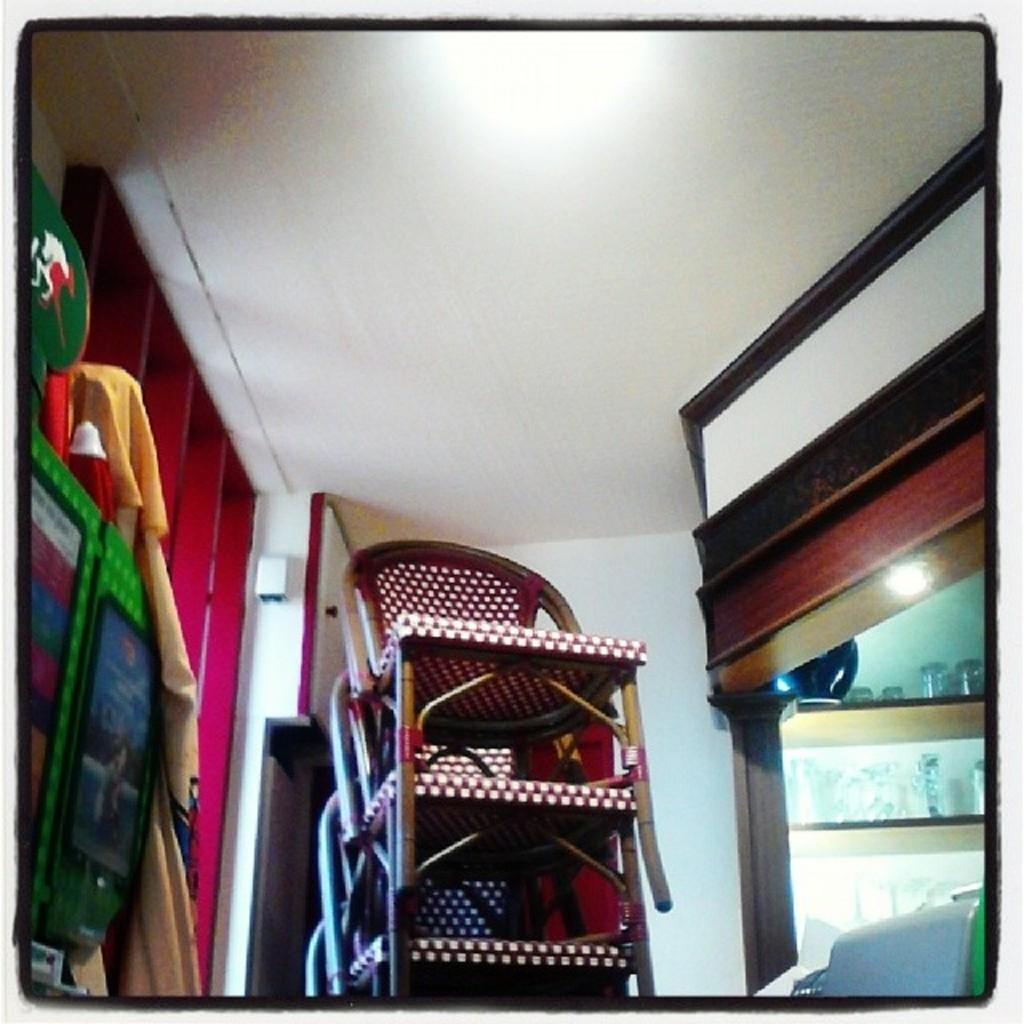What type of furniture is present in the image? There are chairs in the image. What can be seen hanging on the walls in the image? There are glasses in racks in the image. What type of items are visible on the chairs or hanging from them? There are clothes in the image. What can be seen in the background of the image? There is a wall visible in the background of the image. Can you tell me what time the plane is scheduled to arrive in the image? There is no plane present in the image, so it is not possible to determine the arrival time. What type of camera is being used to take the picture in the image? The image does not show a camera being used, so it is not possible to determine the type of camera. 